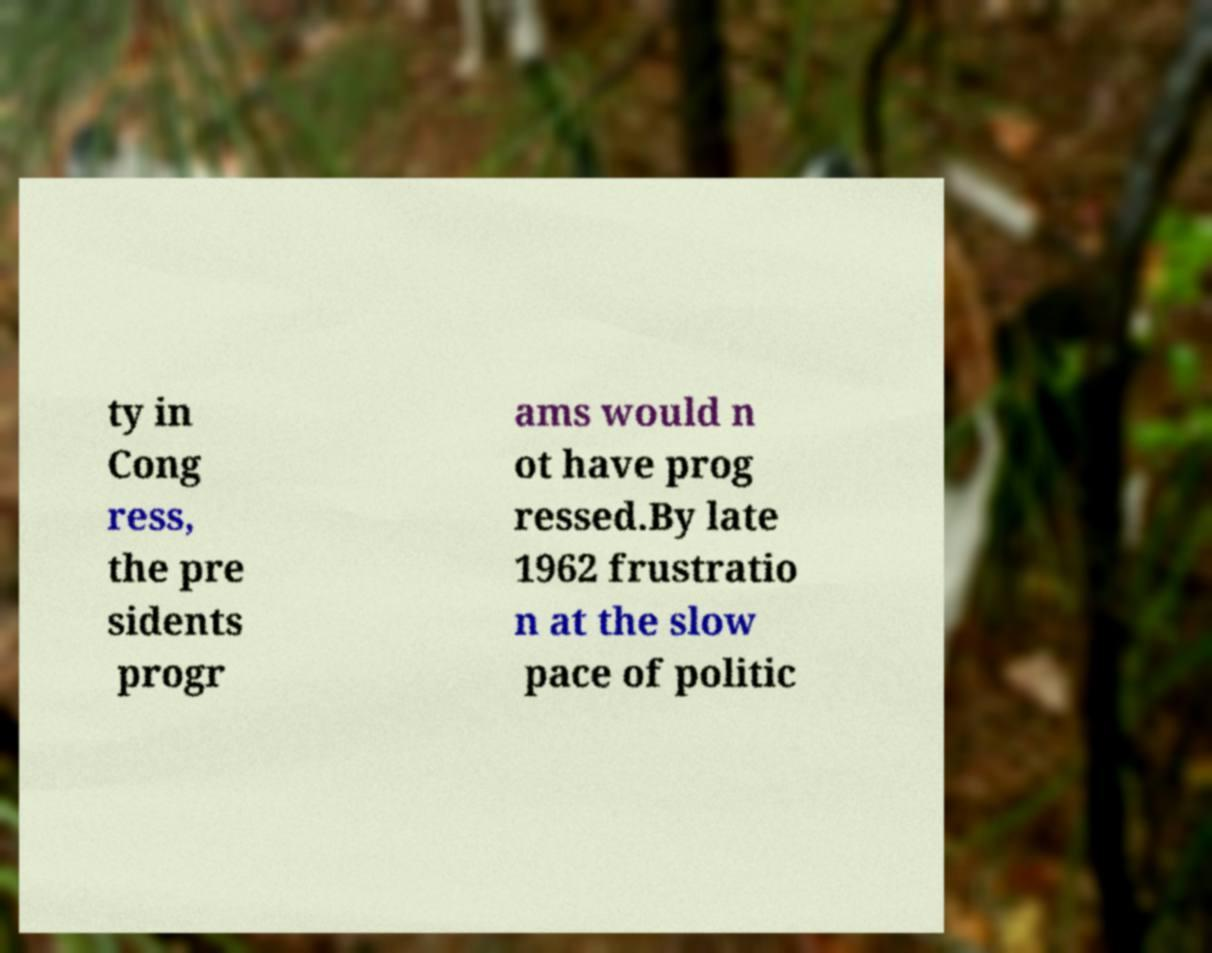Please read and relay the text visible in this image. What does it say? ty in Cong ress, the pre sidents progr ams would n ot have prog ressed.By late 1962 frustratio n at the slow pace of politic 